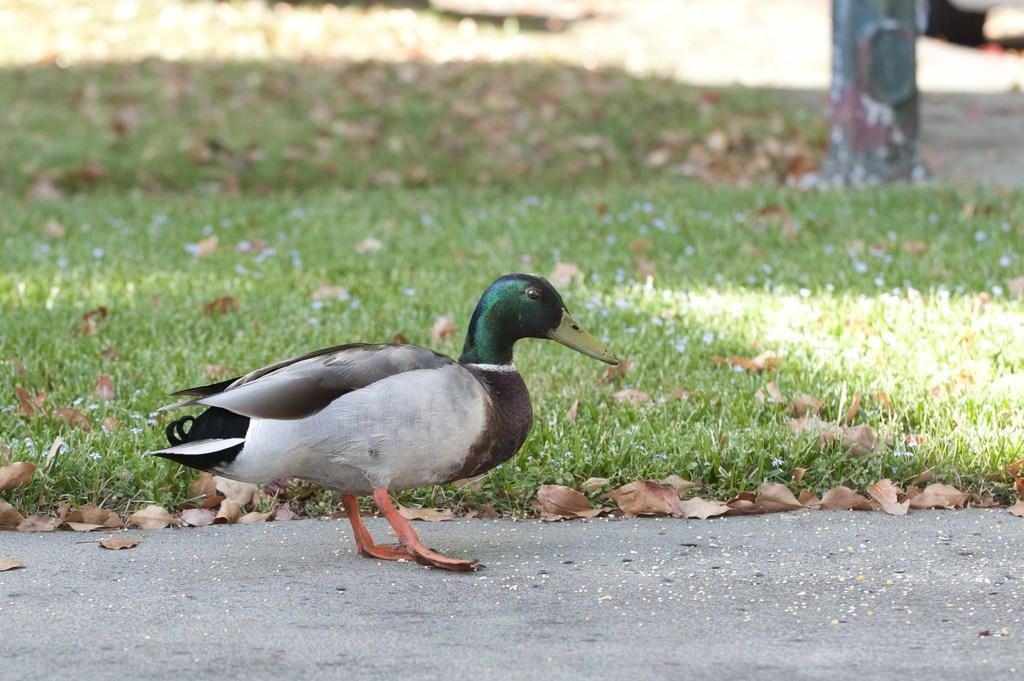What type of outdoor area is visible in the image? There is a small garden in the image. What can be found on the ground in the garden? Dried leaves are present in the image. What else is visible in the image besides the garden? There is a road in the image. What type of animal can be seen in the image? A duck is standing in the image. What type of knife is being used to cut the trousers in the image? There is no knife or trousers present in the image; it features a small garden, dried leaves, a road, and a duck. 